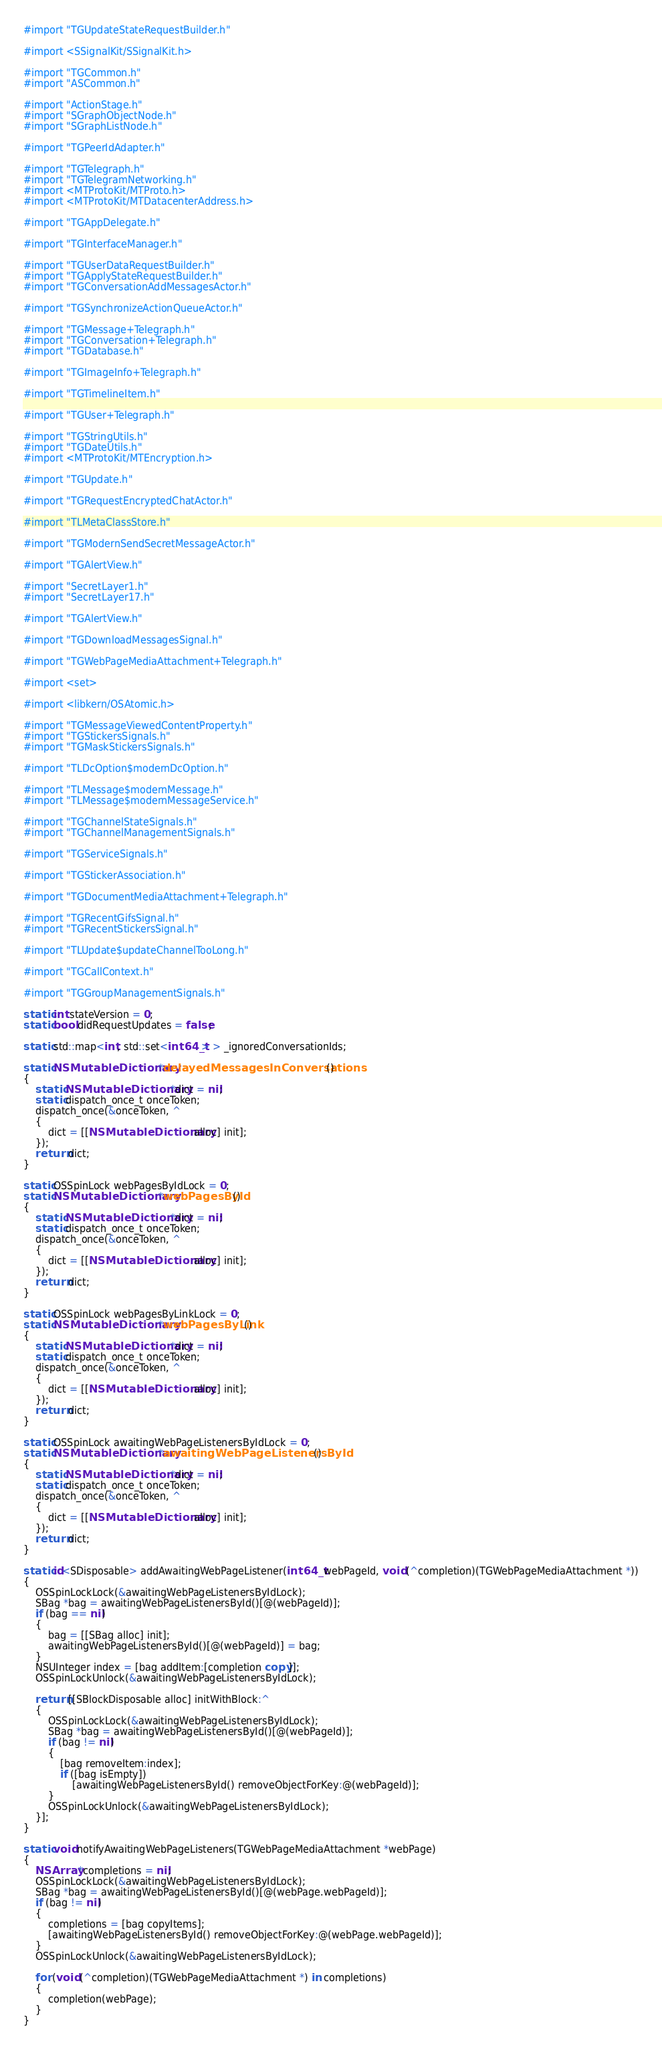Convert code to text. <code><loc_0><loc_0><loc_500><loc_500><_ObjectiveC_>#import "TGUpdateStateRequestBuilder.h"

#import <SSignalKit/SSignalKit.h>

#import "TGCommon.h"
#import "ASCommon.h"

#import "ActionStage.h"
#import "SGraphObjectNode.h"
#import "SGraphListNode.h"

#import "TGPeerIdAdapter.h"

#import "TGTelegraph.h"
#import "TGTelegramNetworking.h"
#import <MTProtoKit/MTProto.h>
#import <MTProtoKit/MTDatacenterAddress.h>

#import "TGAppDelegate.h"

#import "TGInterfaceManager.h"

#import "TGUserDataRequestBuilder.h"
#import "TGApplyStateRequestBuilder.h"
#import "TGConversationAddMessagesActor.h"

#import "TGSynchronizeActionQueueActor.h"

#import "TGMessage+Telegraph.h"
#import "TGConversation+Telegraph.h"
#import "TGDatabase.h"

#import "TGImageInfo+Telegraph.h"

#import "TGTimelineItem.h"

#import "TGUser+Telegraph.h"

#import "TGStringUtils.h"
#import "TGDateUtils.h"
#import <MTProtoKit/MTEncryption.h>

#import "TGUpdate.h"

#import "TGRequestEncryptedChatActor.h"

#import "TLMetaClassStore.h"

#import "TGModernSendSecretMessageActor.h"

#import "TGAlertView.h"

#import "SecretLayer1.h"
#import "SecretLayer17.h"

#import "TGAlertView.h"

#import "TGDownloadMessagesSignal.h"

#import "TGWebPageMediaAttachment+Telegraph.h"

#import <set>

#import <libkern/OSAtomic.h>

#import "TGMessageViewedContentProperty.h"
#import "TGStickersSignals.h"
#import "TGMaskStickersSignals.h"

#import "TLDcOption$modernDcOption.h"

#import "TLMessage$modernMessage.h"
#import "TLMessage$modernMessageService.h"

#import "TGChannelStateSignals.h"
#import "TGChannelManagementSignals.h"

#import "TGServiceSignals.h"

#import "TGStickerAssociation.h"

#import "TGDocumentMediaAttachment+Telegraph.h"

#import "TGRecentGifsSignal.h"
#import "TGRecentStickersSignal.h"

#import "TLUpdate$updateChannelTooLong.h"

#import "TGCallContext.h"

#import "TGGroupManagementSignals.h"

static int stateVersion = 0;
static bool didRequestUpdates = false;

static std::map<int, std::set<int64_t> > _ignoredConversationIds;

static NSMutableDictionary *delayedMessagesInConversations()
{
    static NSMutableDictionary *dict = nil;
    static dispatch_once_t onceToken;
    dispatch_once(&onceToken, ^
    {
        dict = [[NSMutableDictionary alloc] init];
    });
    return dict;
}

static OSSpinLock webPagesByIdLock = 0;
static NSMutableDictionary *webPagesById()
{
    static NSMutableDictionary *dict = nil;
    static dispatch_once_t onceToken;
    dispatch_once(&onceToken, ^
    {
        dict = [[NSMutableDictionary alloc] init];
    });
    return dict;
}

static OSSpinLock webPagesByLinkLock = 0;
static NSMutableDictionary *webPagesByLink()
{
    static NSMutableDictionary *dict = nil;
    static dispatch_once_t onceToken;
    dispatch_once(&onceToken, ^
    {
        dict = [[NSMutableDictionary alloc] init];
    });
    return dict;
}

static OSSpinLock awaitingWebPageListenersByIdLock = 0;
static NSMutableDictionary *awaitingWebPageListenersById()
{
    static NSMutableDictionary *dict = nil;
    static dispatch_once_t onceToken;
    dispatch_once(&onceToken, ^
    {
        dict = [[NSMutableDictionary alloc] init];
    });
    return dict;
}

static id<SDisposable> addAwaitingWebPageListener(int64_t webPageId, void (^completion)(TGWebPageMediaAttachment *))
{
    OSSpinLockLock(&awaitingWebPageListenersByIdLock);
    SBag *bag = awaitingWebPageListenersById()[@(webPageId)];
    if (bag == nil)
    {
        bag = [[SBag alloc] init];
        awaitingWebPageListenersById()[@(webPageId)] = bag;
    }
    NSUInteger index = [bag addItem:[completion copy]];
    OSSpinLockUnlock(&awaitingWebPageListenersByIdLock);
    
    return [[SBlockDisposable alloc] initWithBlock:^
    {
        OSSpinLockLock(&awaitingWebPageListenersByIdLock);
        SBag *bag = awaitingWebPageListenersById()[@(webPageId)];
        if (bag != nil)
        {
            [bag removeItem:index];
            if ([bag isEmpty])
                [awaitingWebPageListenersById() removeObjectForKey:@(webPageId)];
        }
        OSSpinLockUnlock(&awaitingWebPageListenersByIdLock);
    }];
}

static void notifyAwaitingWebPageListeners(TGWebPageMediaAttachment *webPage)
{
    NSArray *completions = nil;
    OSSpinLockLock(&awaitingWebPageListenersByIdLock);
    SBag *bag = awaitingWebPageListenersById()[@(webPage.webPageId)];
    if (bag != nil)
    {
        completions = [bag copyItems];
        [awaitingWebPageListenersById() removeObjectForKey:@(webPage.webPageId)];
    }
    OSSpinLockUnlock(&awaitingWebPageListenersByIdLock);
    
    for (void (^completion)(TGWebPageMediaAttachment *) in completions)
    {
        completion(webPage);
    }
}
</code> 